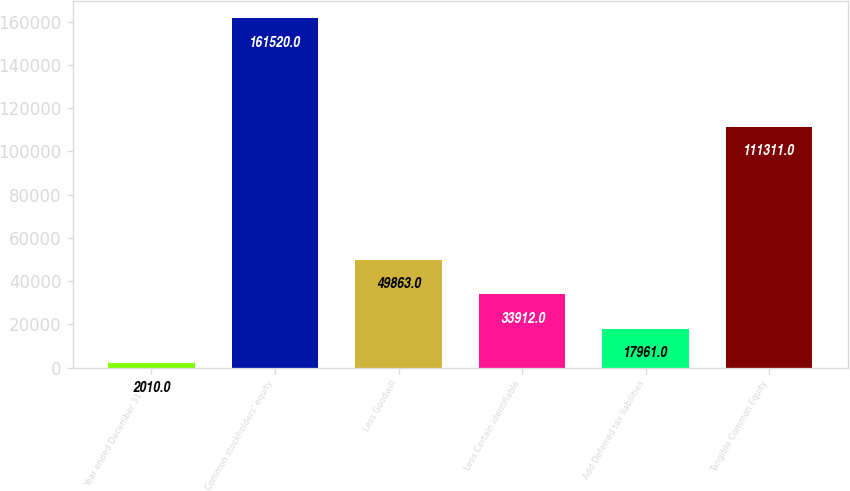<chart> <loc_0><loc_0><loc_500><loc_500><bar_chart><fcel>Year ended December 31 (in<fcel>Common stockholders' equity<fcel>Less Goodwill<fcel>Less Certain identifiable<fcel>Add Deferred tax liabilities<fcel>Tangible Common Equity<nl><fcel>2010<fcel>161520<fcel>49863<fcel>33912<fcel>17961<fcel>111311<nl></chart> 